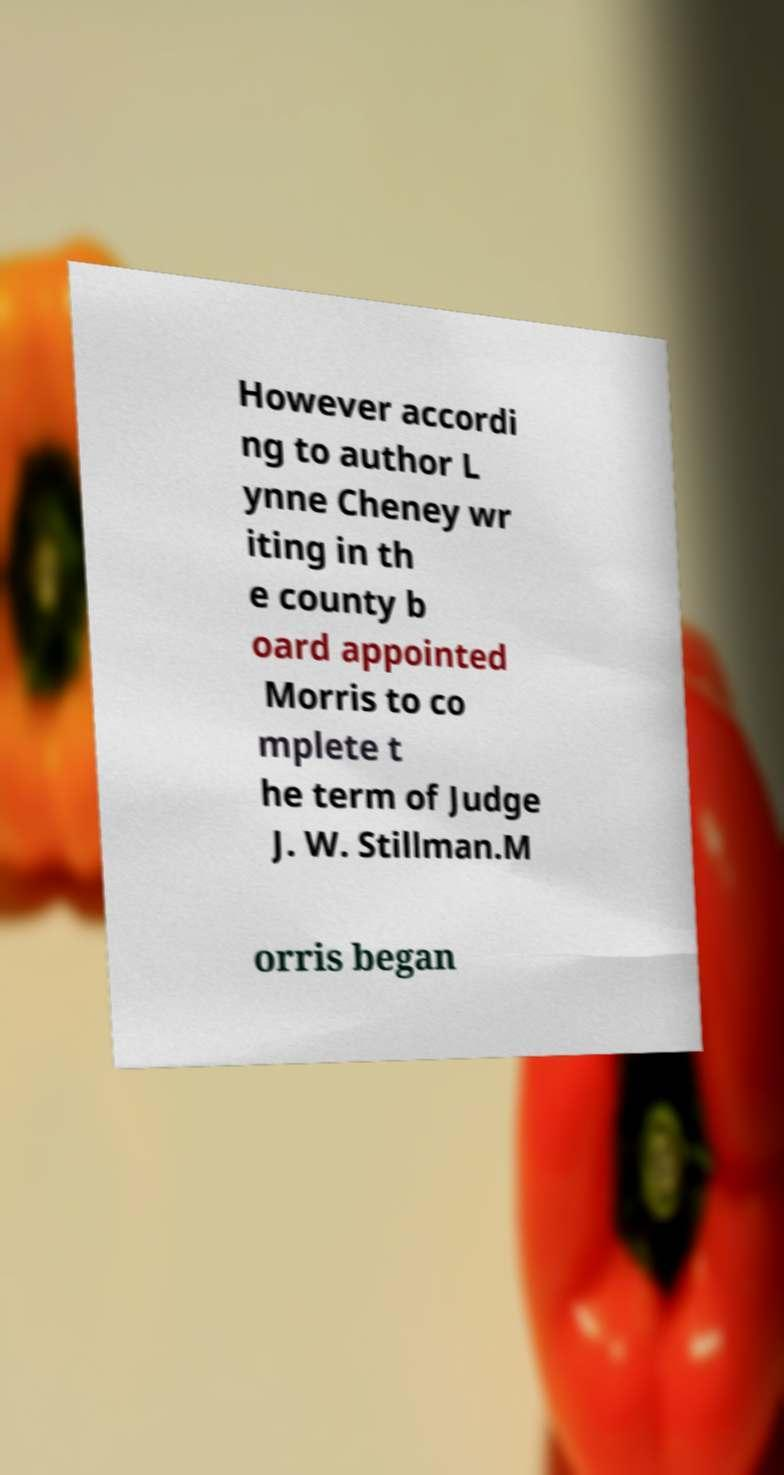Please read and relay the text visible in this image. What does it say? However accordi ng to author L ynne Cheney wr iting in th e county b oard appointed Morris to co mplete t he term of Judge J. W. Stillman.M orris began 